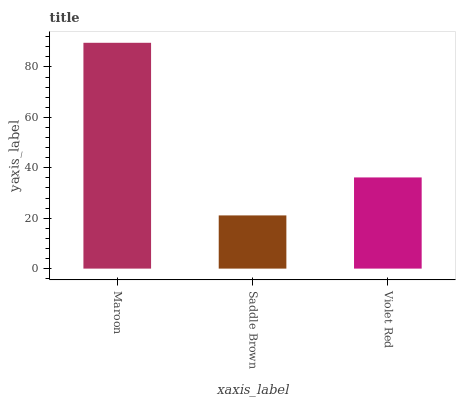Is Saddle Brown the minimum?
Answer yes or no. Yes. Is Maroon the maximum?
Answer yes or no. Yes. Is Violet Red the minimum?
Answer yes or no. No. Is Violet Red the maximum?
Answer yes or no. No. Is Violet Red greater than Saddle Brown?
Answer yes or no. Yes. Is Saddle Brown less than Violet Red?
Answer yes or no. Yes. Is Saddle Brown greater than Violet Red?
Answer yes or no. No. Is Violet Red less than Saddle Brown?
Answer yes or no. No. Is Violet Red the high median?
Answer yes or no. Yes. Is Violet Red the low median?
Answer yes or no. Yes. Is Saddle Brown the high median?
Answer yes or no. No. Is Maroon the low median?
Answer yes or no. No. 